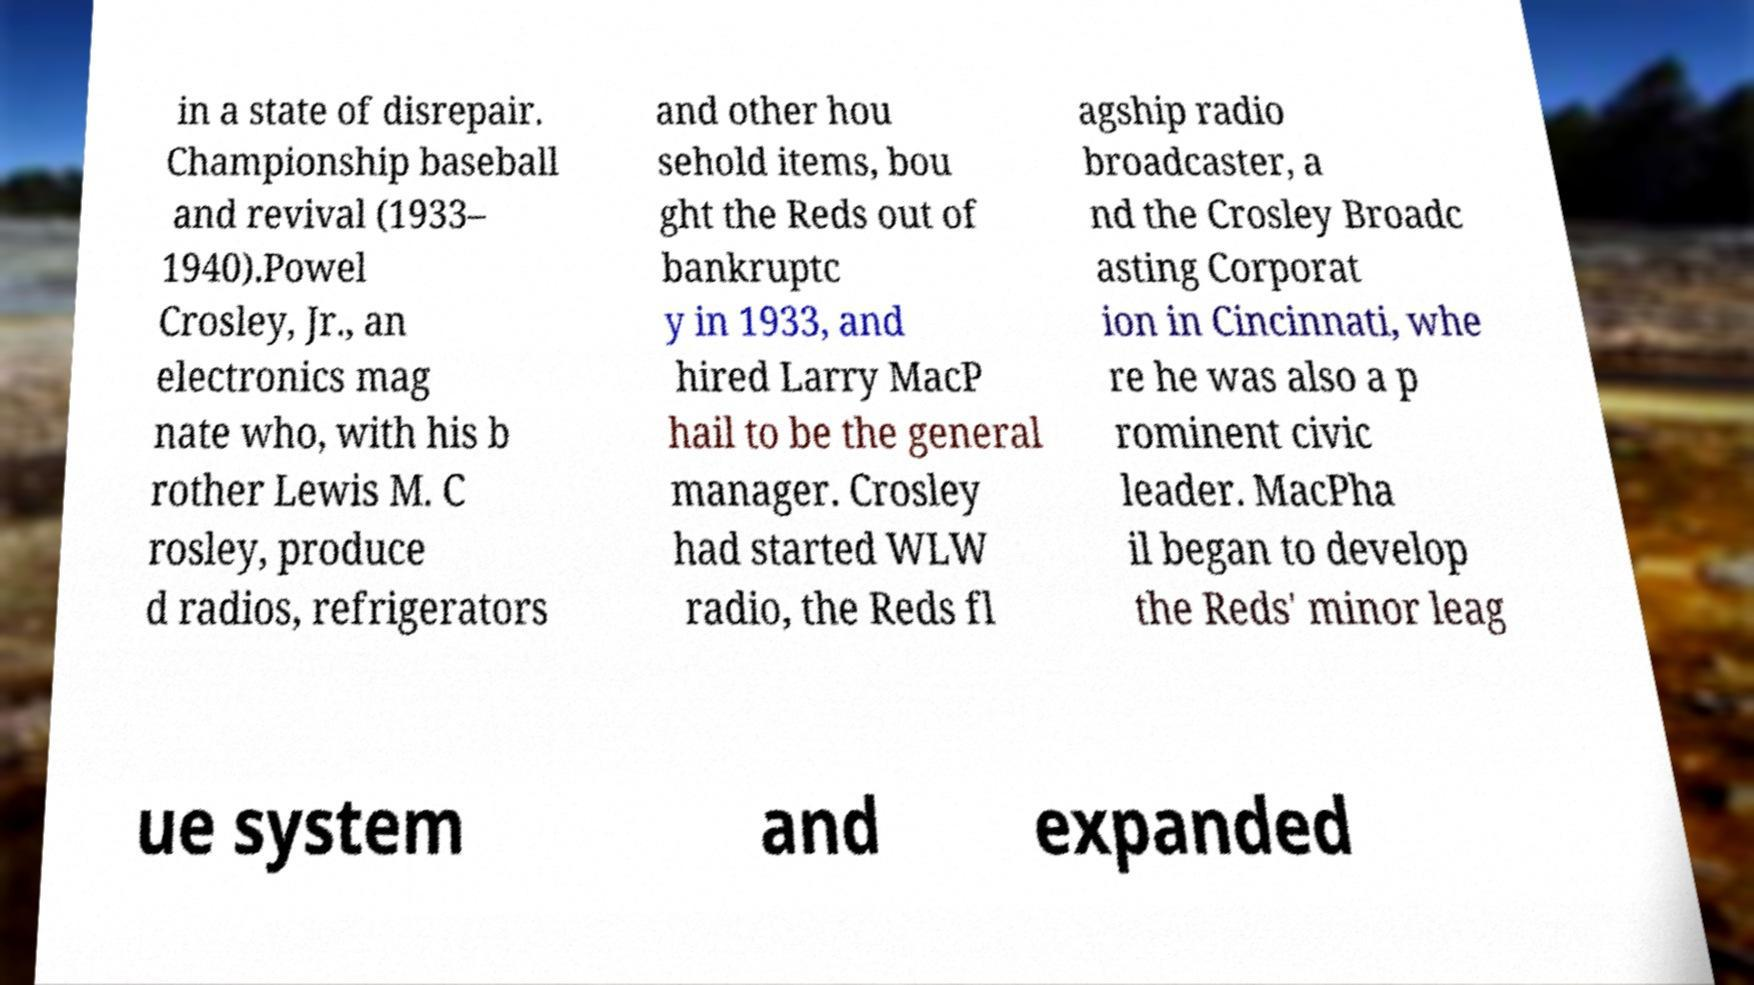Could you extract and type out the text from this image? in a state of disrepair. Championship baseball and revival (1933– 1940).Powel Crosley, Jr., an electronics mag nate who, with his b rother Lewis M. C rosley, produce d radios, refrigerators and other hou sehold items, bou ght the Reds out of bankruptc y in 1933, and hired Larry MacP hail to be the general manager. Crosley had started WLW radio, the Reds fl agship radio broadcaster, a nd the Crosley Broadc asting Corporat ion in Cincinnati, whe re he was also a p rominent civic leader. MacPha il began to develop the Reds' minor leag ue system and expanded 